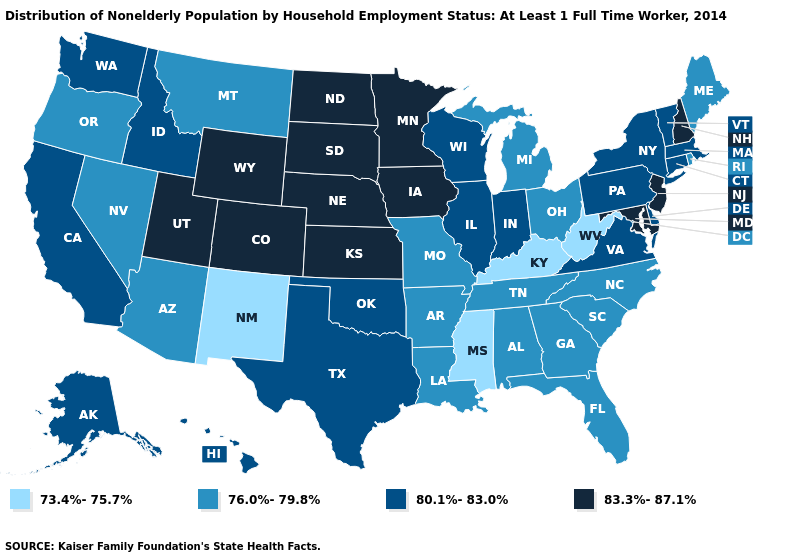Does the map have missing data?
Short answer required. No. Does Utah have a lower value than Montana?
Give a very brief answer. No. What is the value of Rhode Island?
Keep it brief. 76.0%-79.8%. How many symbols are there in the legend?
Quick response, please. 4. What is the lowest value in the USA?
Short answer required. 73.4%-75.7%. Which states have the lowest value in the USA?
Write a very short answer. Kentucky, Mississippi, New Mexico, West Virginia. What is the lowest value in the USA?
Quick response, please. 73.4%-75.7%. Does the first symbol in the legend represent the smallest category?
Be succinct. Yes. What is the value of Mississippi?
Answer briefly. 73.4%-75.7%. What is the value of Kansas?
Write a very short answer. 83.3%-87.1%. Name the states that have a value in the range 83.3%-87.1%?
Be succinct. Colorado, Iowa, Kansas, Maryland, Minnesota, Nebraska, New Hampshire, New Jersey, North Dakota, South Dakota, Utah, Wyoming. Name the states that have a value in the range 83.3%-87.1%?
Quick response, please. Colorado, Iowa, Kansas, Maryland, Minnesota, Nebraska, New Hampshire, New Jersey, North Dakota, South Dakota, Utah, Wyoming. What is the lowest value in states that border South Carolina?
Quick response, please. 76.0%-79.8%. Does New York have the same value as Tennessee?
Write a very short answer. No. 